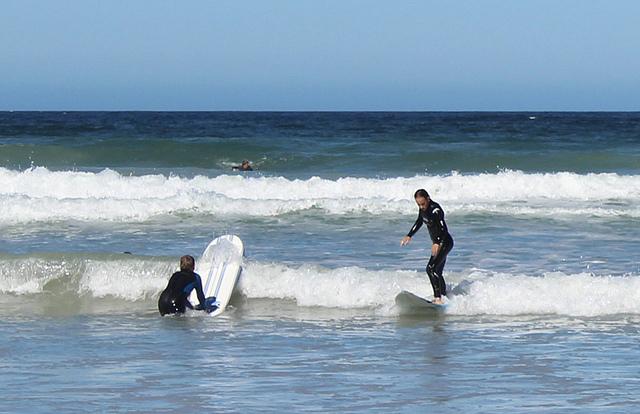Is the water code?
Give a very brief answer. No. Is it a high tide?
Quick response, please. Yes. How many people are in the water?
Keep it brief. 3. 